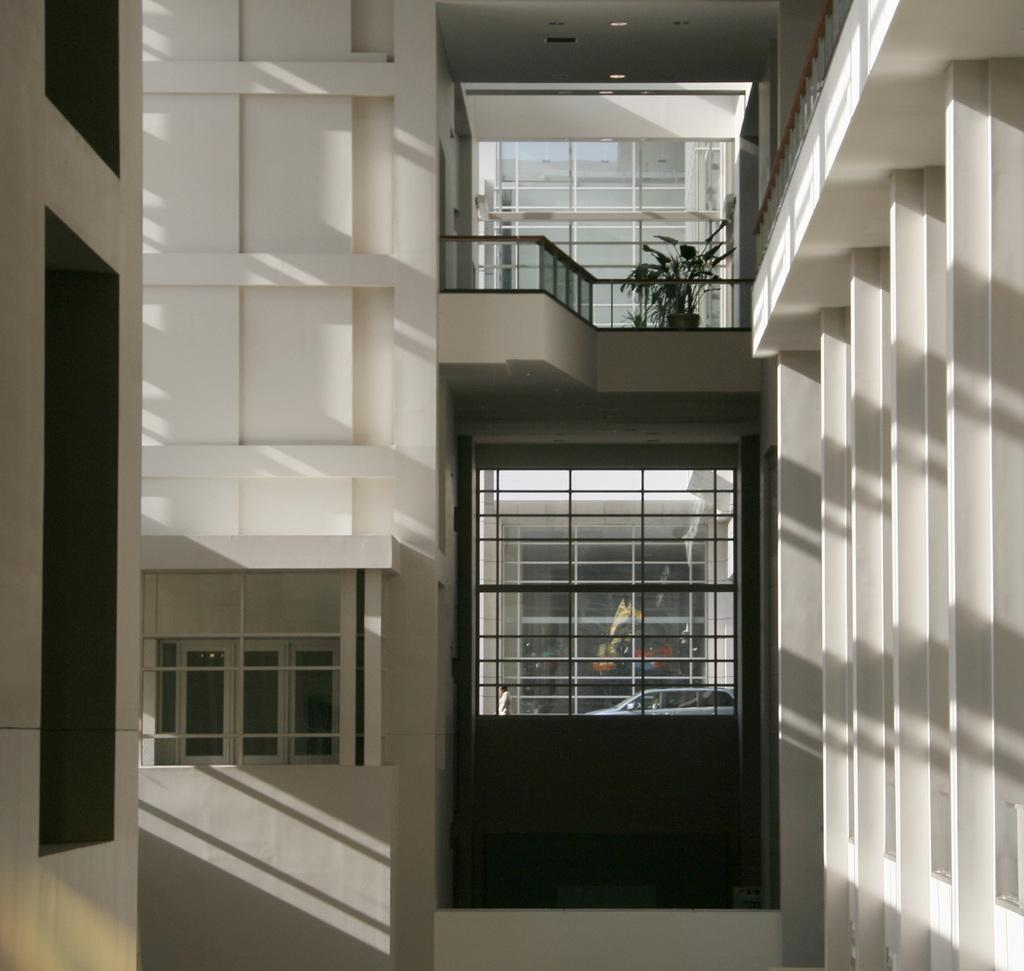What is in the foreground of the image? There are walls of a building in the foreground of the image. What type of material is used for the windows in the image? Glass windows are present in the image. What feature can be seen near the windows? Railing is visible in the image. Is there any vegetation present in the image? Yes, there is a plant in the image. Can you see the mother bear and her cubs playing near the stream in the image? There is no mother bear, cubs, or stream present in the image. 